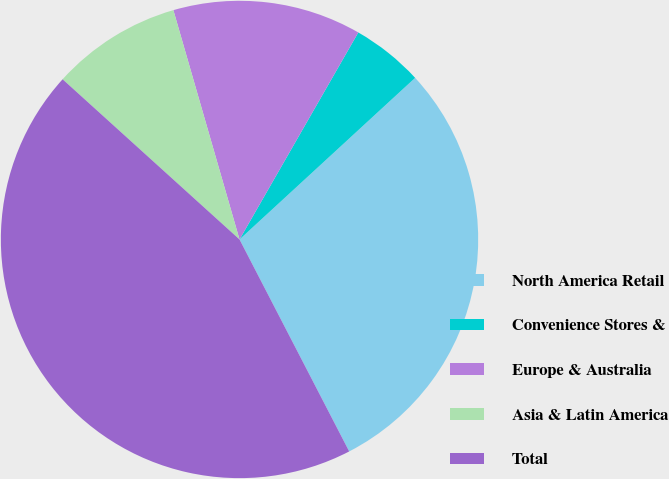<chart> <loc_0><loc_0><loc_500><loc_500><pie_chart><fcel>North America Retail<fcel>Convenience Stores &<fcel>Europe & Australia<fcel>Asia & Latin America<fcel>Total<nl><fcel>29.24%<fcel>4.87%<fcel>12.76%<fcel>8.82%<fcel>44.31%<nl></chart> 